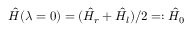<formula> <loc_0><loc_0><loc_500><loc_500>\hat { H } ( \lambda = 0 ) = ( \hat { H } _ { r } + \hat { H } _ { l } ) / 2 = \colon \hat { H } _ { 0 }</formula> 